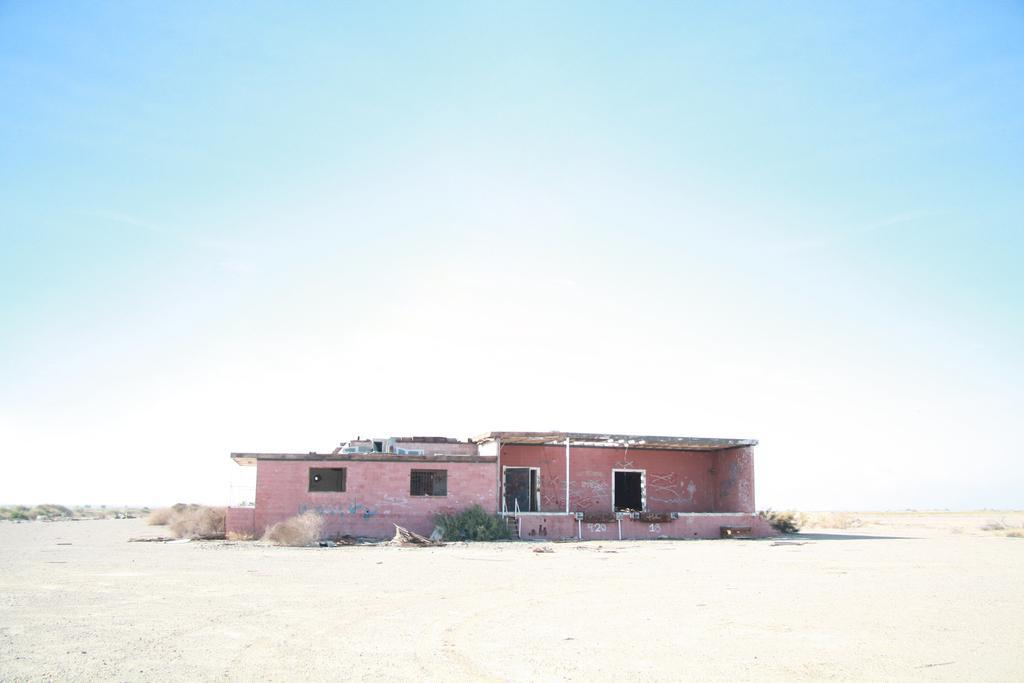In one or two sentences, can you explain what this image depicts? This picture is taken from outside of the city. In this image, in the middle, we can see a house, window and a door. On the left side, we can see some plants and trees. On the right side, we can see some plants. At the top, we can see a sky, at the bottom, we can see some plants and a land with some stones. 